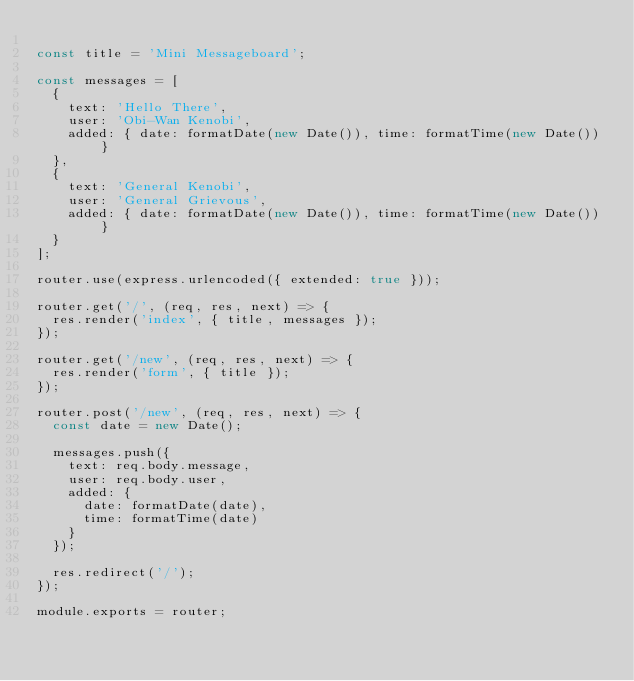<code> <loc_0><loc_0><loc_500><loc_500><_JavaScript_>
const title = 'Mini Messageboard';

const messages = [
  {
    text: 'Hello There',
    user: 'Obi-Wan Kenobi',
    added: { date: formatDate(new Date()), time: formatTime(new Date()) }
  },
  {
    text: 'General Kenobi',
    user: 'General Grievous',
    added: { date: formatDate(new Date()), time: formatTime(new Date()) }
  }
];

router.use(express.urlencoded({ extended: true }));

router.get('/', (req, res, next) => {
  res.render('index', { title, messages });
});

router.get('/new', (req, res, next) => {
  res.render('form', { title });
});

router.post('/new', (req, res, next) => {
  const date = new Date();

  messages.push({
    text: req.body.message,
    user: req.body.user,
    added: {
      date: formatDate(date),
      time: formatTime(date)
    }
  });

  res.redirect('/');
});

module.exports = router;
</code> 